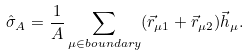<formula> <loc_0><loc_0><loc_500><loc_500>\hat { \sigma } _ { A } = \frac { 1 } { A } \sum _ { \mu \in b o u n d a r y } ( \vec { r } _ { \mu 1 } + \vec { r } _ { \mu 2 } ) \vec { h } _ { \mu } .</formula> 